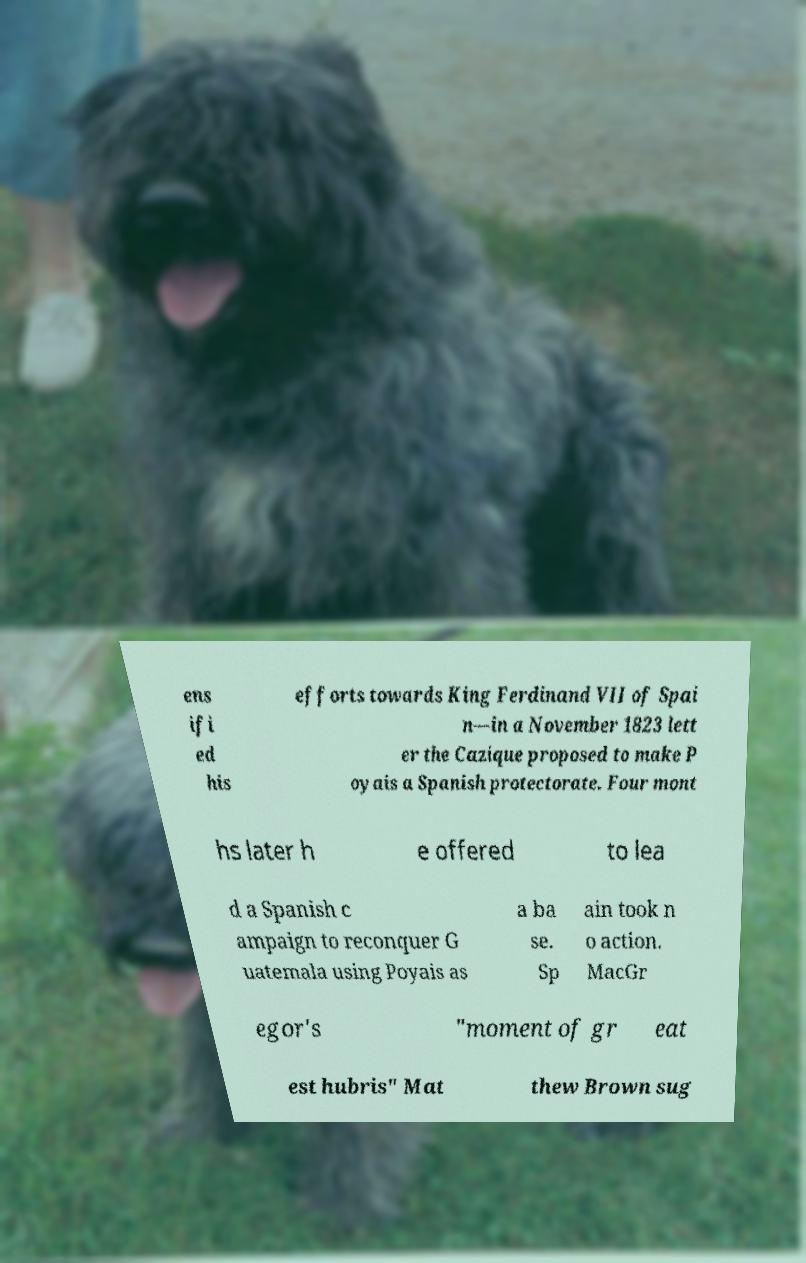Please read and relay the text visible in this image. What does it say? ens ifi ed his efforts towards King Ferdinand VII of Spai n—in a November 1823 lett er the Cazique proposed to make P oyais a Spanish protectorate. Four mont hs later h e offered to lea d a Spanish c ampaign to reconquer G uatemala using Poyais as a ba se. Sp ain took n o action. MacGr egor's "moment of gr eat est hubris" Mat thew Brown sug 